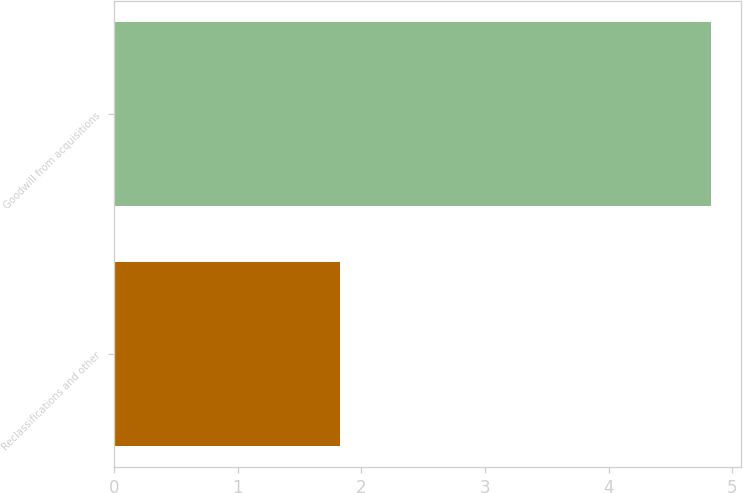Convert chart to OTSL. <chart><loc_0><loc_0><loc_500><loc_500><bar_chart><fcel>Reclassifications and other<fcel>Goodwill from acquisitions<nl><fcel>1.83<fcel>4.83<nl></chart> 